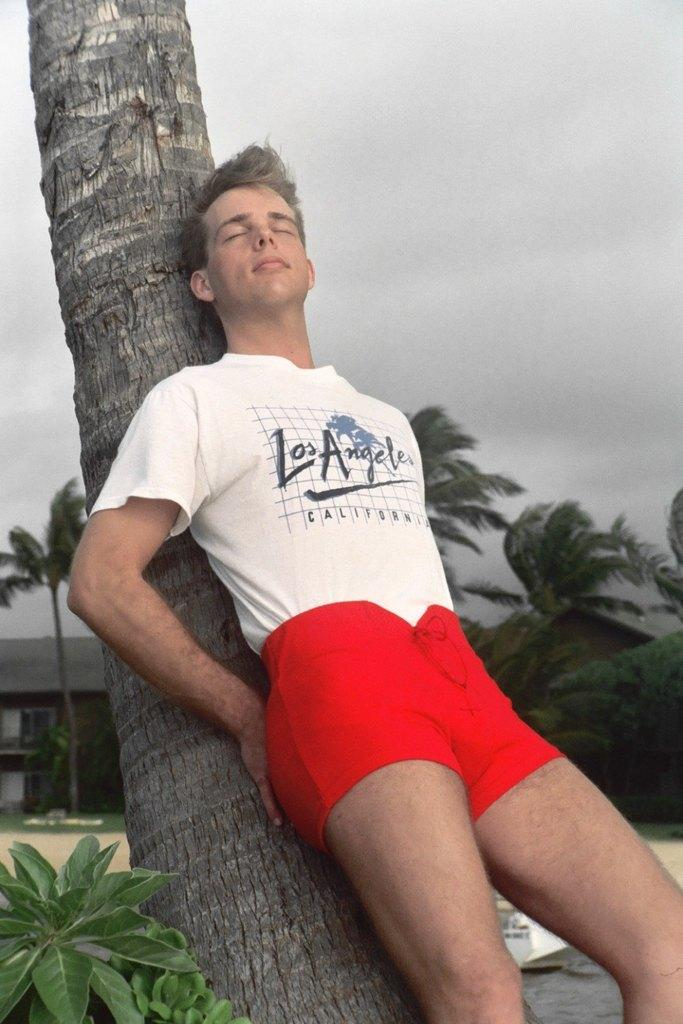What is the man in the image doing? The man is lying on a tree trunk in the image. What type of natural elements can be seen in the image? There are plants and trees in the image. What structures can be seen in the background of the image? There is a house, a roof, and other objects visible in the background. What is visible in the sky in the background of the image? There are clouds in the sky in the background of the image. What type of bread is the man eating while lying on the tree trunk? There is no bread present in the image; the man is lying on a tree trunk without any food. What branch is the man holding onto while lying on the tree trunk? There is no branch visible in the image; the man is lying on a tree trunk without any branches nearby. 